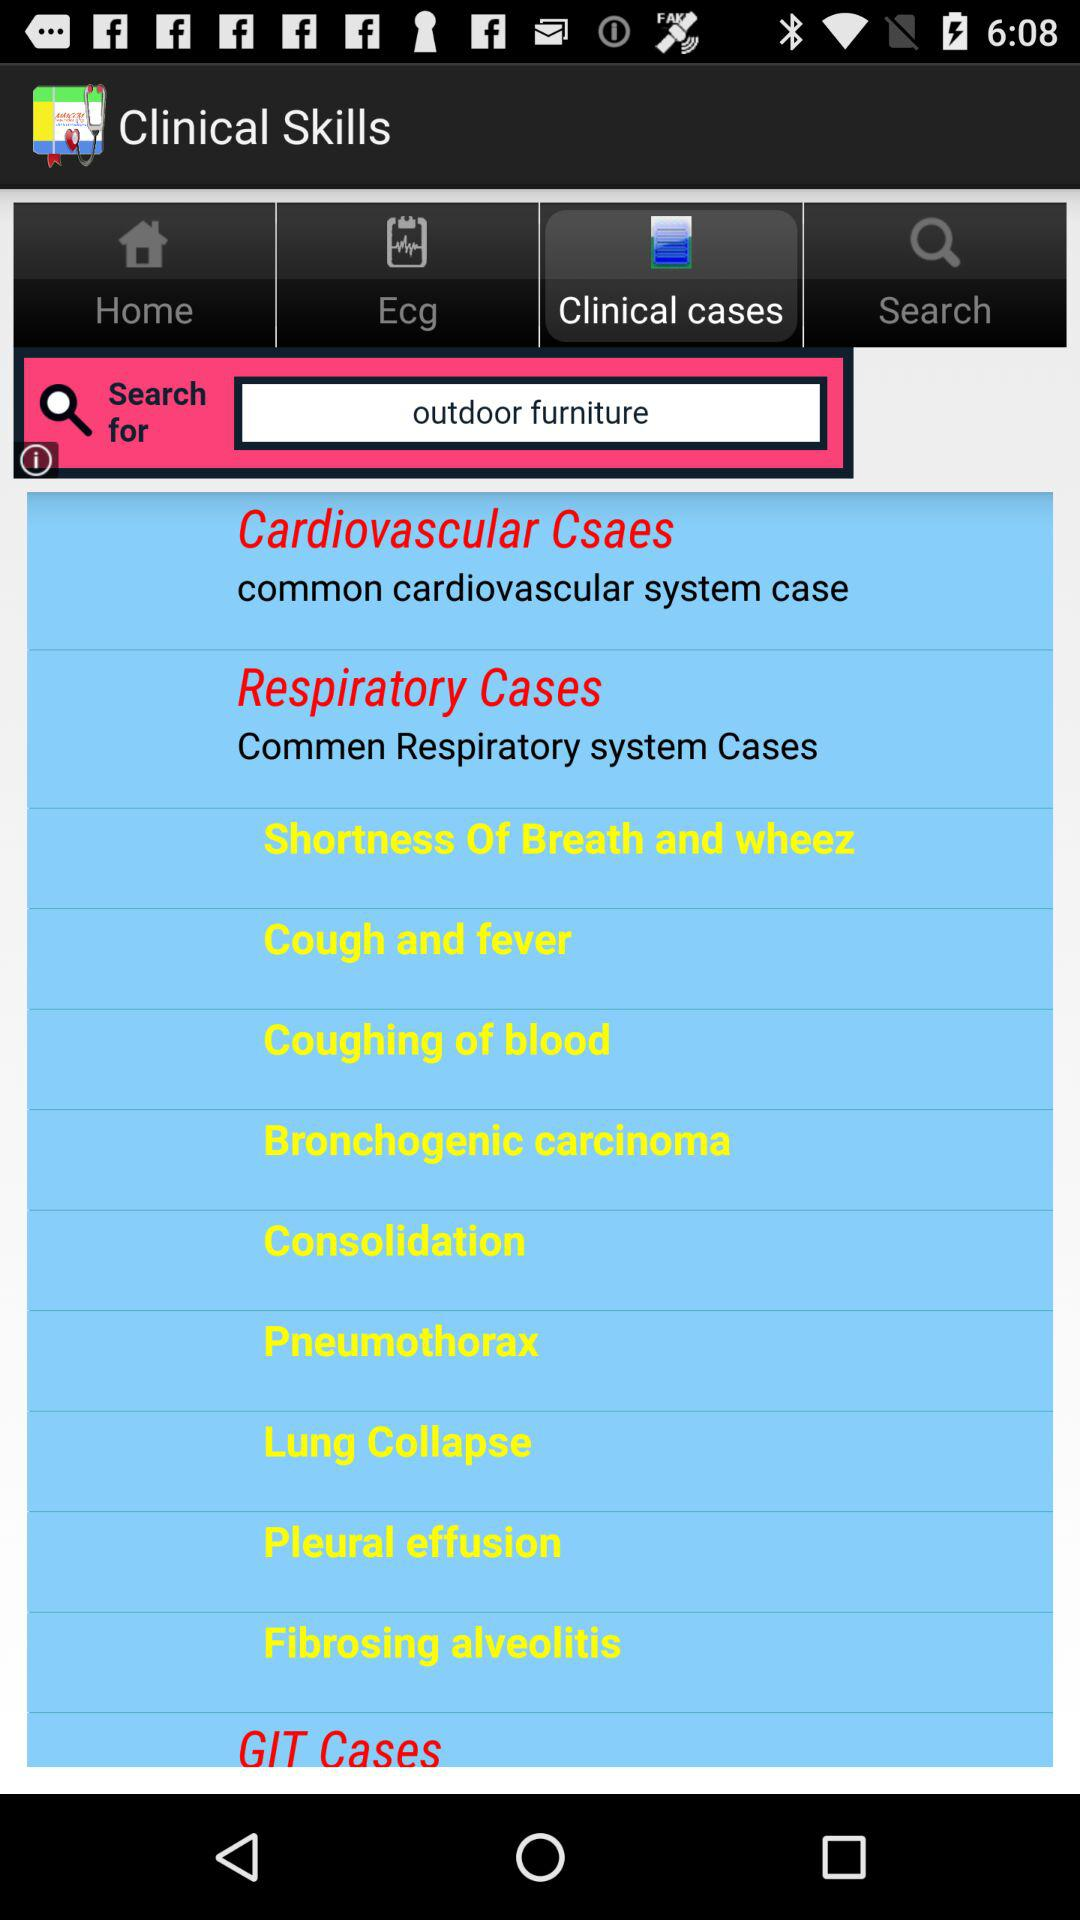Which tab has been selected? The selected tab is "Clinical cases". 